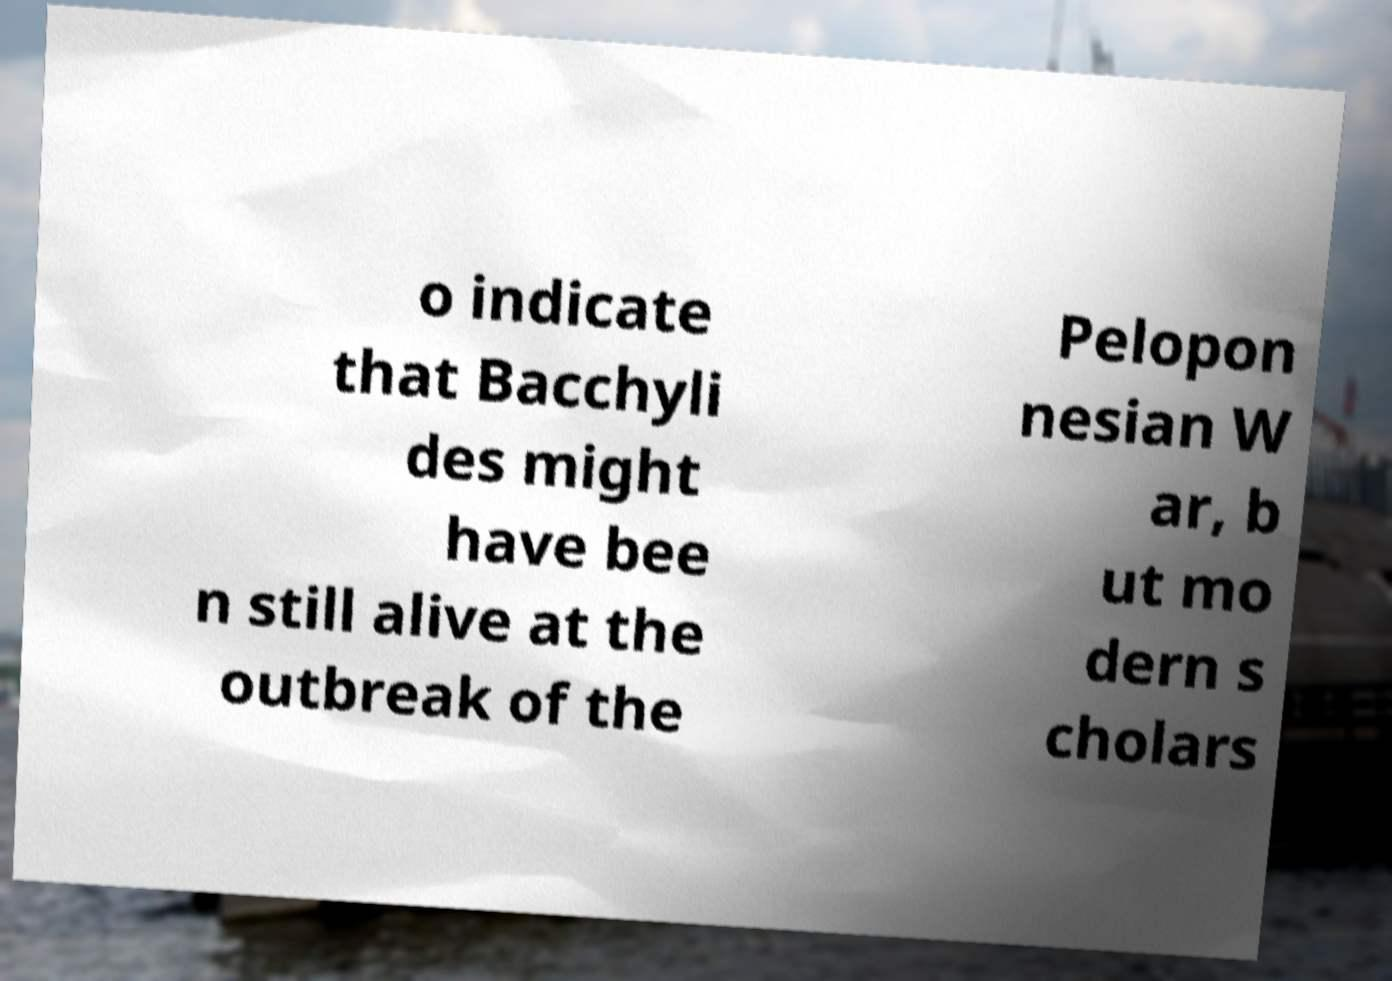Please read and relay the text visible in this image. What does it say? o indicate that Bacchyli des might have bee n still alive at the outbreak of the Pelopon nesian W ar, b ut mo dern s cholars 